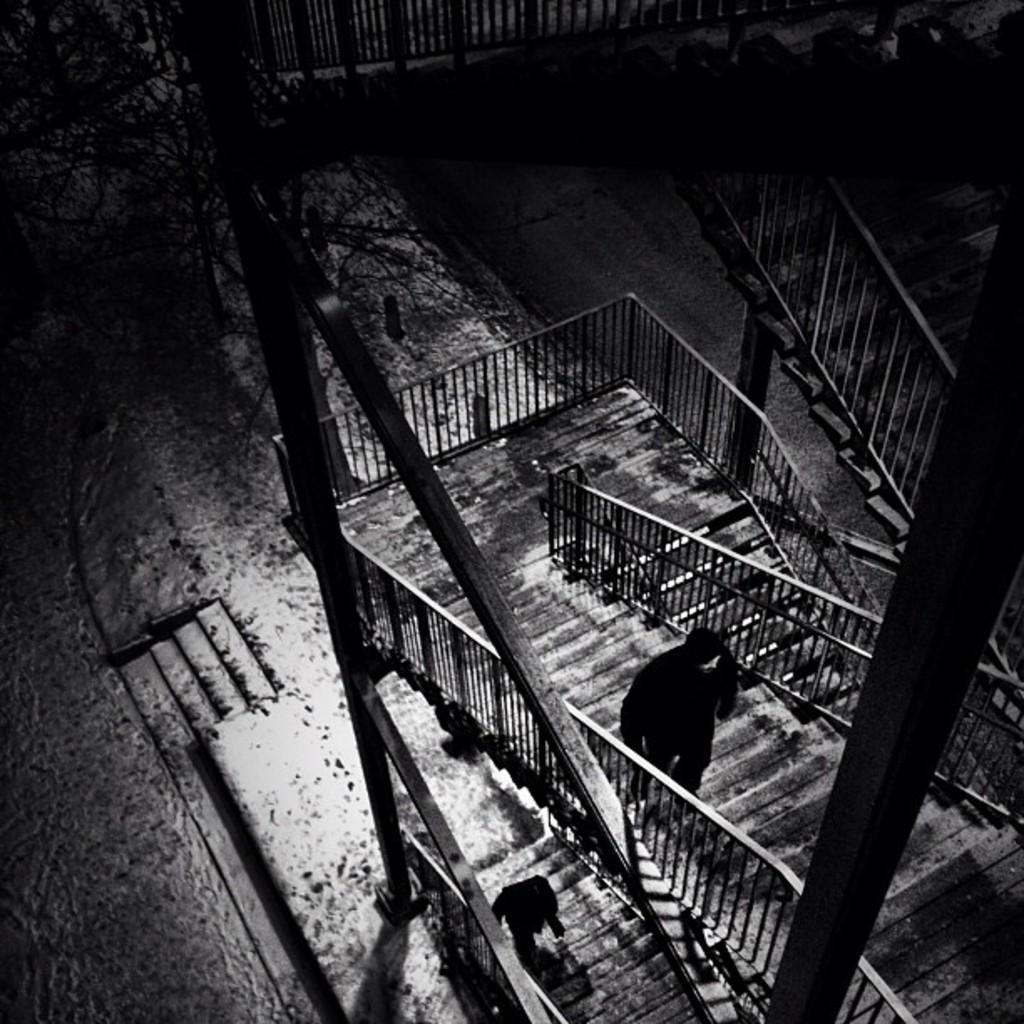What is the color scheme of the image? The image is black and white. What are the two people in the image doing? The two people in the image are walking in the center. What type of structures can be seen in the image? There are fences and staircases visible in the image. What type of vegetation is present in the image? There is at least one tree in the image. Can you describe any other objects in the image? There are a few other objects in the image, but their specific details are not mentioned in the provided facts. Where is the nest of the owl located in the image? There is no nest or owl present in the image. What type of key is being used to open the door in the image? There is no door or key present in the image. 